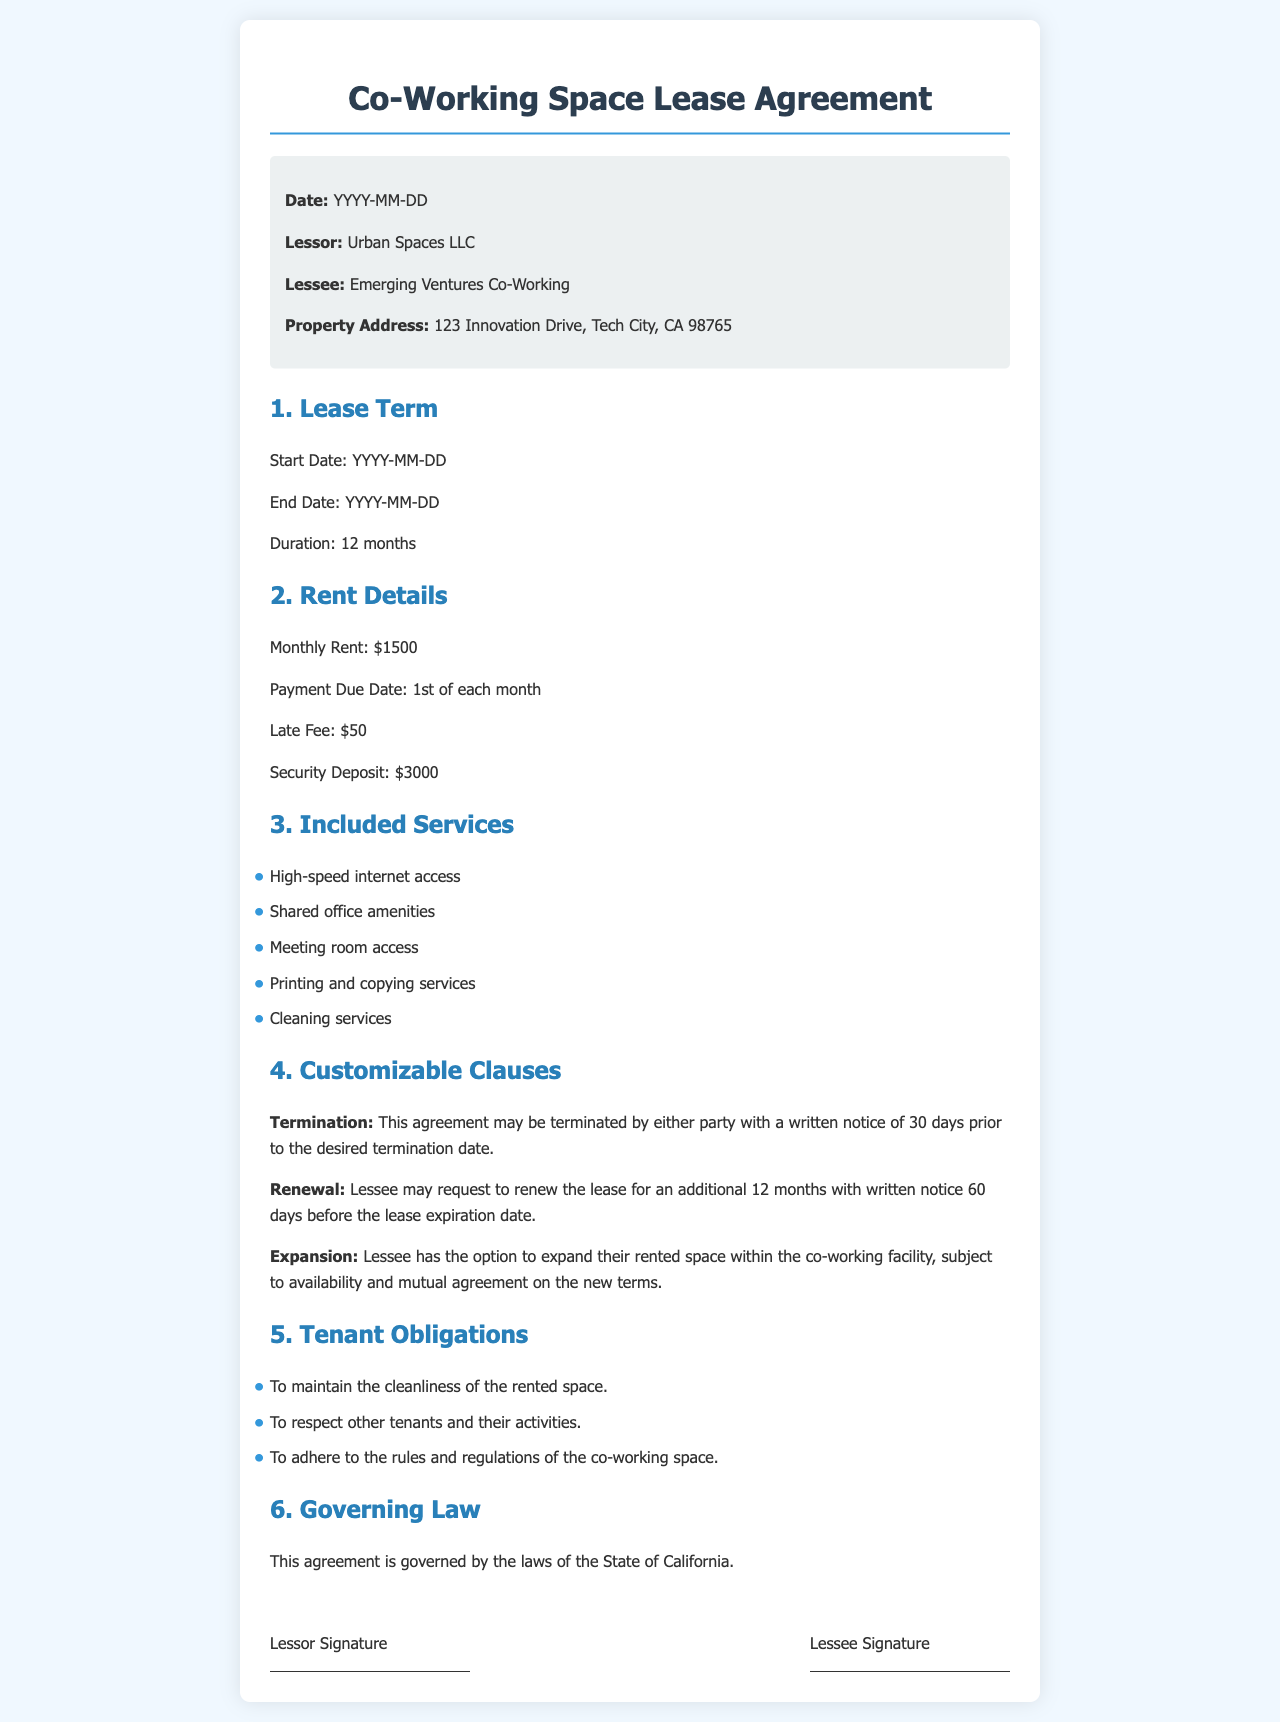What is the name of the lessor? The lessor is the entity that owns the property being leased, which is stated in the document.
Answer: Urban Spaces LLC What is the monthly rent amount? The monthly rent is specified under the Rent Details section of the document.
Answer: $1500 What is the duration of the lease? The duration of the lease is mentioned in the Lease Term section, indicating how long the agreement will last.
Answer: 12 months What is the late fee for missed payments? The late fee is outlined in the Rent Details section of the document, specifying the penalty for late payments.
Answer: $50 What is required for lease termination? The termination clause specifies the conditions needed to terminate the lease agreement.
Answer: Written notice of 30 days What services are included in the lease? The Included Services section lists amenities provided as part of the lease agreement.
Answer: High-speed internet access How many days in advance must the lessee provide notice for renewal? The renewal clause specifies the notice period required to request a lease renewal.
Answer: 60 days What is the security deposit amount? The security deposit is mentioned in the Rent Details section of the document and serves as a safeguard for the lessor.
Answer: $3000 Which law governs this agreement? The Governing Law section identifies the jurisdiction under which the lease agreement operates.
Answer: State of California 